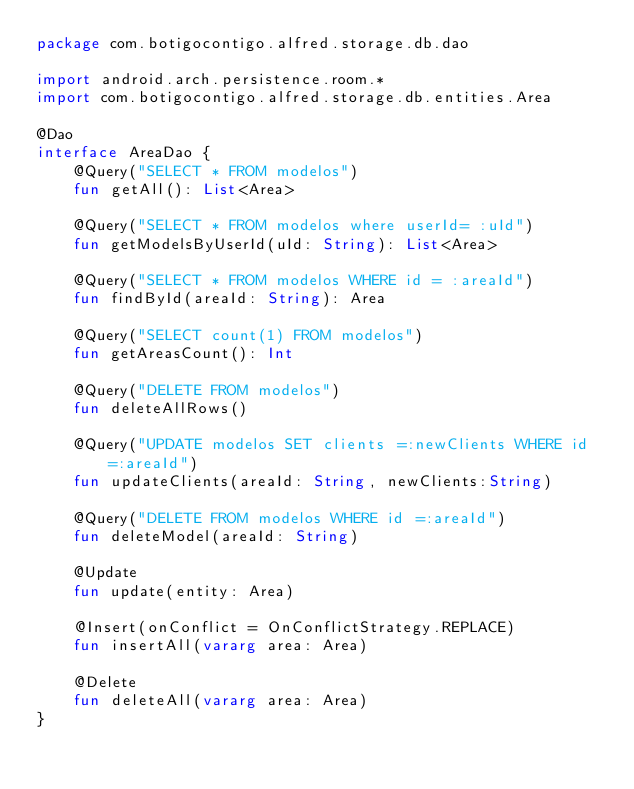Convert code to text. <code><loc_0><loc_0><loc_500><loc_500><_Kotlin_>package com.botigocontigo.alfred.storage.db.dao

import android.arch.persistence.room.*
import com.botigocontigo.alfred.storage.db.entities.Area

@Dao
interface AreaDao {
    @Query("SELECT * FROM modelos")
    fun getAll(): List<Area>

    @Query("SELECT * FROM modelos where userId= :uId")
    fun getModelsByUserId(uId: String): List<Area>

    @Query("SELECT * FROM modelos WHERE id = :areaId")
    fun findById(areaId: String): Area

    @Query("SELECT count(1) FROM modelos")
    fun getAreasCount(): Int

    @Query("DELETE FROM modelos")
    fun deleteAllRows()

    @Query("UPDATE modelos SET clients =:newClients WHERE id =:areaId")
    fun updateClients(areaId: String, newClients:String)

    @Query("DELETE FROM modelos WHERE id =:areaId")
    fun deleteModel(areaId: String)

    @Update
    fun update(entity: Area)

    @Insert(onConflict = OnConflictStrategy.REPLACE)
    fun insertAll(vararg area: Area)

    @Delete
    fun deleteAll(vararg area: Area)
}</code> 